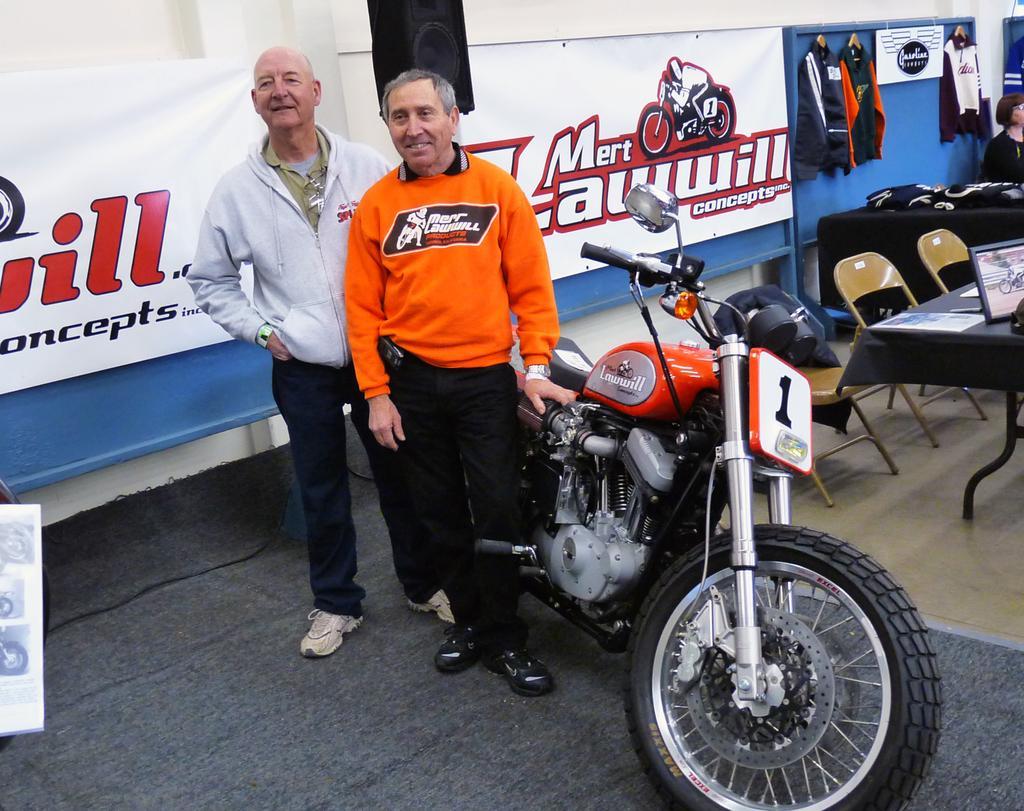Describe this image in one or two sentences. There are two men in the picture and a bike among them the one is wearing the orange color hoodie and the other is wearing ash color jacket and also we have two chairs and three other jackets on the wall. 